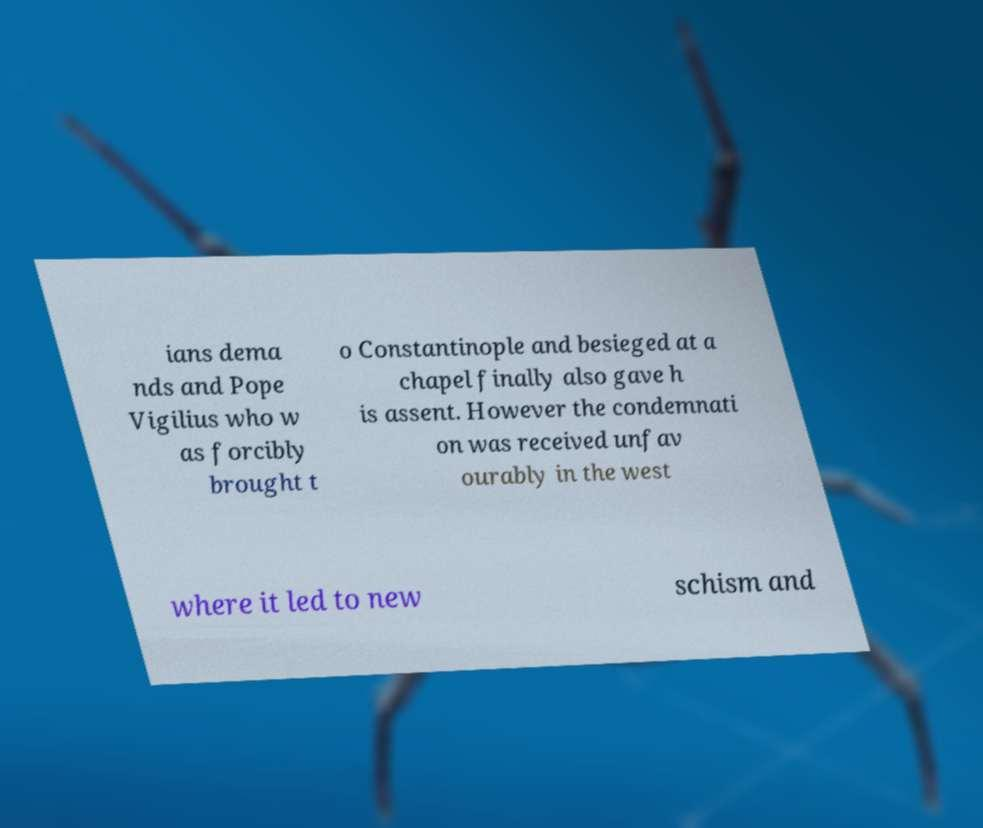Could you assist in decoding the text presented in this image and type it out clearly? ians dema nds and Pope Vigilius who w as forcibly brought t o Constantinople and besieged at a chapel finally also gave h is assent. However the condemnati on was received unfav ourably in the west where it led to new schism and 